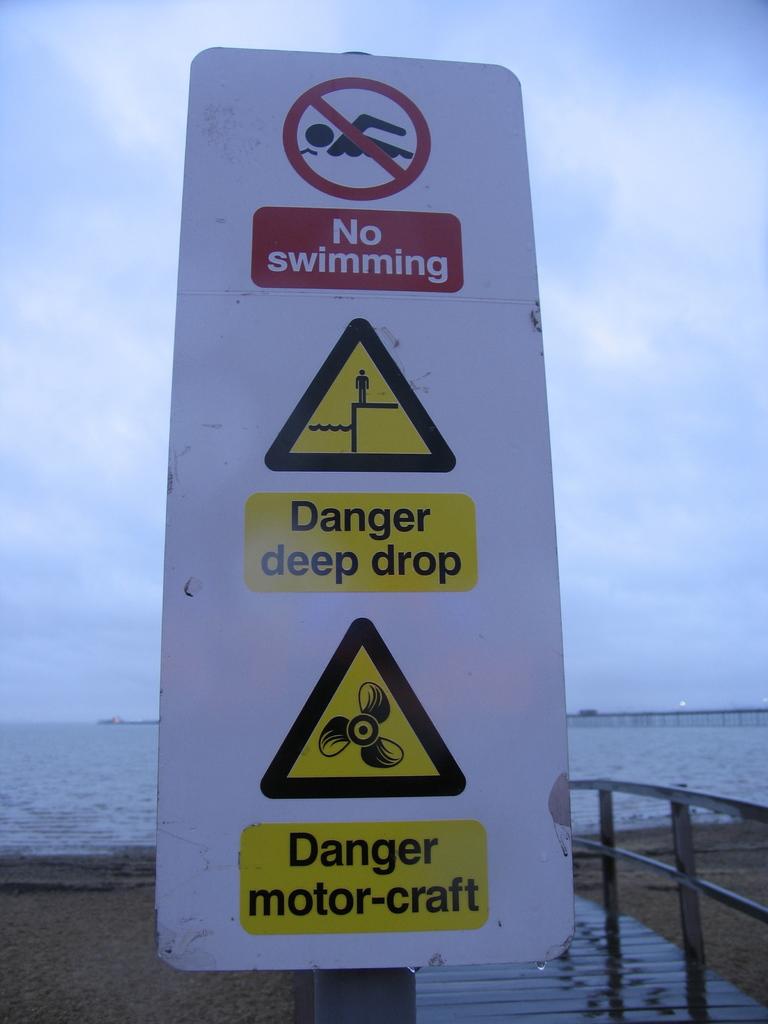What is not allowed on the water?
Your answer should be very brief. Swimming. What is wrote where the red symbol posted at?
Offer a very short reply. No swimming. 